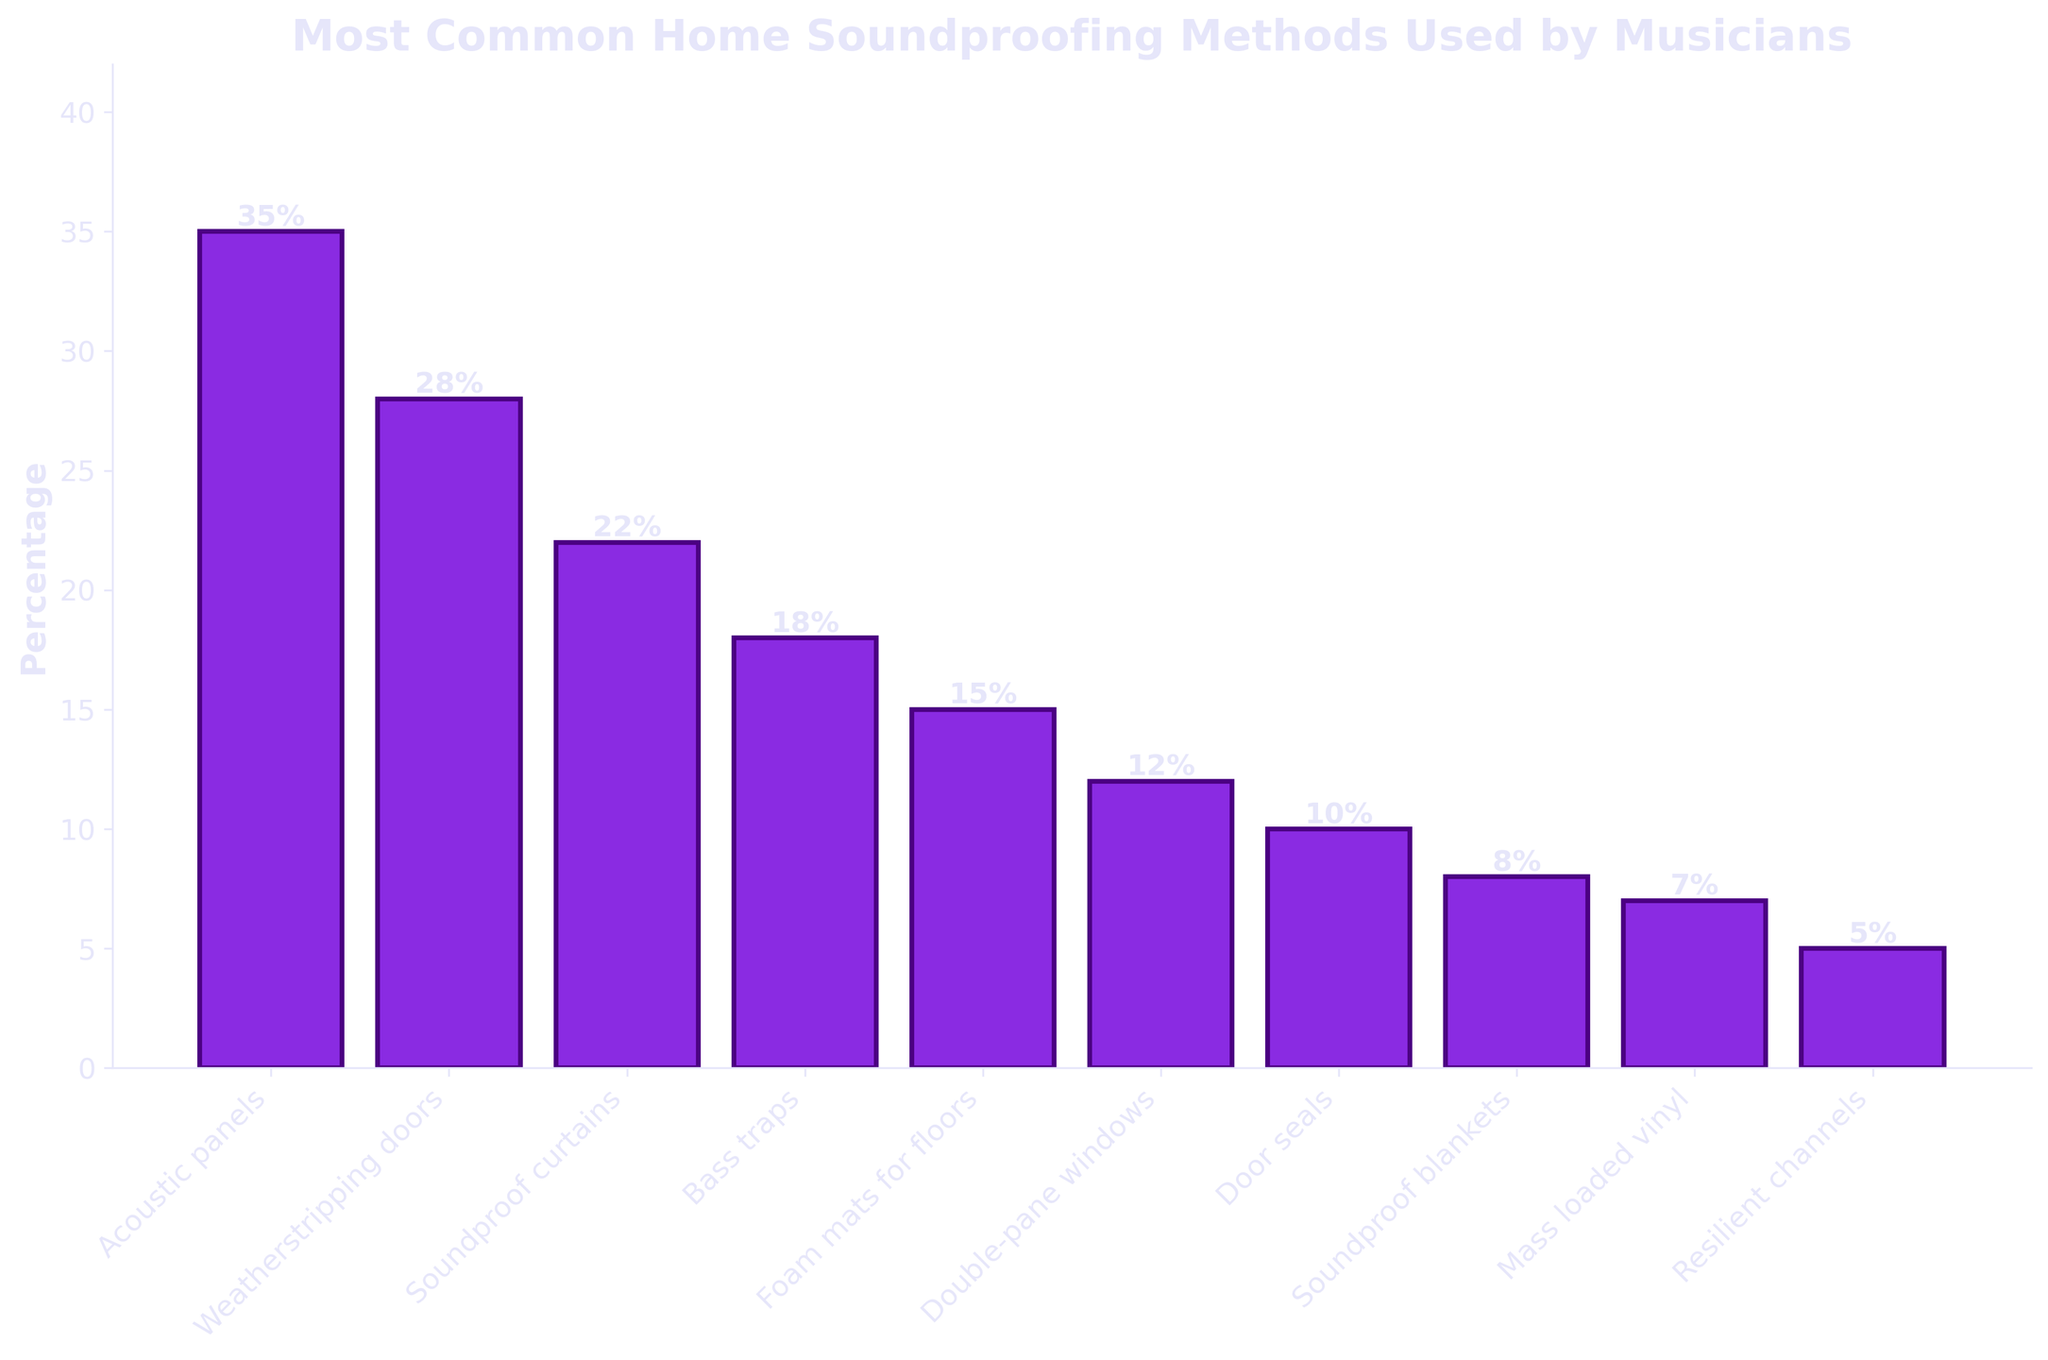Which soundproofing method is the most commonly used by musicians? The highest bar in the chart represents the "Acoustic panels" method, which corresponds to the highest percentage of 35%.
Answer: Acoustic panels Which soundproofing method is used the least by musicians? The shortest bar in the chart represents the "Resilient channels" method, corresponding to the lowest percentage of 5%.
Answer: Resilient channels How much more popular are acoustic panels compared to double-pane windows? The percentage for acoustic panels is 35%, and for double-pane windows, it's 12%. The difference is 35% - 12% = 23%.
Answer: 23% What is the total percentage of musicians using soundproof curtains and bass traps? The percentage for soundproof curtains is 22%, and for bass traps, it's 18%. The sum is 22% + 18% = 40%.
Answer: 40% Which three soundproofing methods are used by more than 20% of musicians? The bars for "Acoustic panels" (35%), "Weatherstripping doors" (28%), and "Soundproof curtains" (22%) all have percentages greater than 20%.
Answer: Acoustic panels, Weatherstripping doors, Soundproof curtains Which method has nearly half the popularity of weatherstripping doors? Weatherstripping doors have a percentage of 28%. Half of this would be roughly 14%. The closest method is "Foam mats for floors," which has a percentage of 15%.
Answer: Foam mats for floors How much more popular are the top two methods combined compared to the bottom two methods combined? The top two methods ("Acoustic panels" and "Weatherstripping doors") have percentages of 35% and 28%, summing up to 63%. The bottom two methods ("Mass loaded vinyl" and "Resilient channels") have percentages of 7% and 5%, summing to 12%. The difference is 63% - 12% = 51%.
Answer: 51% What is the average percentage of the bottom five least used methods? The bottom five methods are "Bass traps" (18%), "Foam mats for floors" (15%), "Double-pane windows" (12%), "Door seals" (10%), and "Soundproof blankets" (8%). The sum of these percentages is 18% + 15% + 12% + 10% + 8% = 63%. The average is 63% / 5 = 12.6%.
Answer: 12.6% Are foam mats for floors more popular than bass traps? By comparing the heights of the bars, foam mats for floors have a percentage of 15%, and bass traps have a percentage of 18%. Foam mats for floors are less popular.
Answer: No What is the combined percentage of methods used by fewer than 10% of musicians? The methods "Door seals" (10%), "Soundproof blankets" (8%), "Mass loaded vinyl" (7%), and "Resilient channels" (5%) are used by fewer than 10%. Their sum is 10% + 8% + 7% + 5% = 30%.
Answer: 30% 